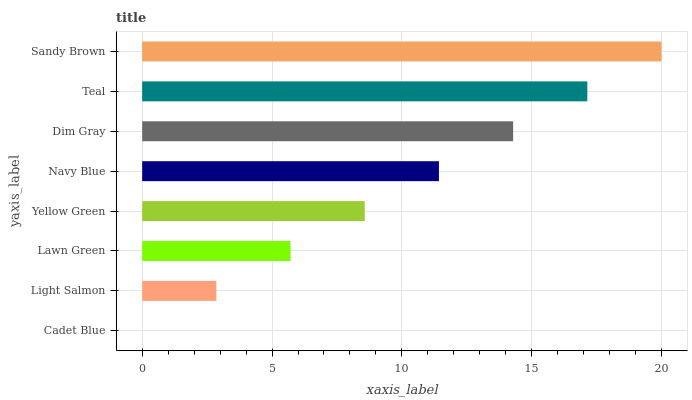Is Cadet Blue the minimum?
Answer yes or no. Yes. Is Sandy Brown the maximum?
Answer yes or no. Yes. Is Light Salmon the minimum?
Answer yes or no. No. Is Light Salmon the maximum?
Answer yes or no. No. Is Light Salmon greater than Cadet Blue?
Answer yes or no. Yes. Is Cadet Blue less than Light Salmon?
Answer yes or no. Yes. Is Cadet Blue greater than Light Salmon?
Answer yes or no. No. Is Light Salmon less than Cadet Blue?
Answer yes or no. No. Is Navy Blue the high median?
Answer yes or no. Yes. Is Yellow Green the low median?
Answer yes or no. Yes. Is Lawn Green the high median?
Answer yes or no. No. Is Light Salmon the low median?
Answer yes or no. No. 